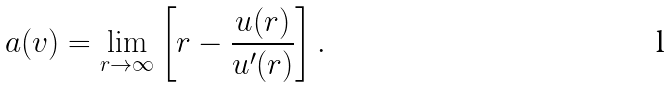Convert formula to latex. <formula><loc_0><loc_0><loc_500><loc_500>a ( v ) = \lim _ { r \to \infty } \left [ r - \frac { u ( r ) } { u ^ { \prime } ( r ) } \right ] .</formula> 